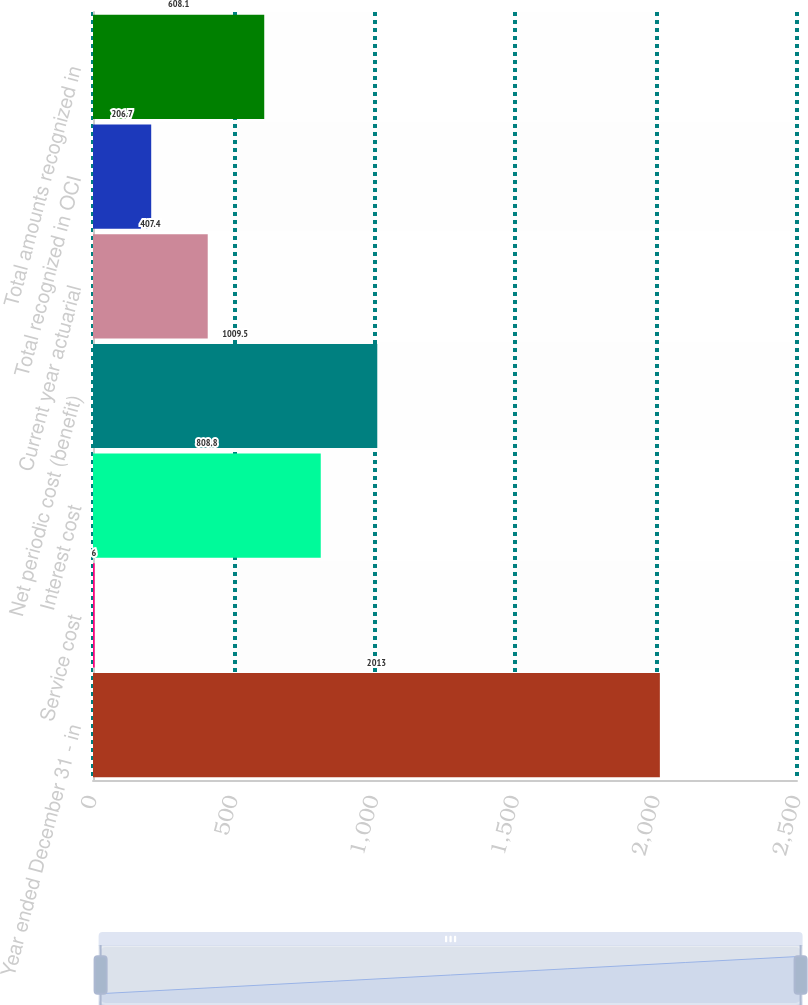<chart> <loc_0><loc_0><loc_500><loc_500><bar_chart><fcel>Year ended December 31 - in<fcel>Service cost<fcel>Interest cost<fcel>Net periodic cost (benefit)<fcel>Current year actuarial<fcel>Total recognized in OCI<fcel>Total amounts recognized in<nl><fcel>2013<fcel>6<fcel>808.8<fcel>1009.5<fcel>407.4<fcel>206.7<fcel>608.1<nl></chart> 